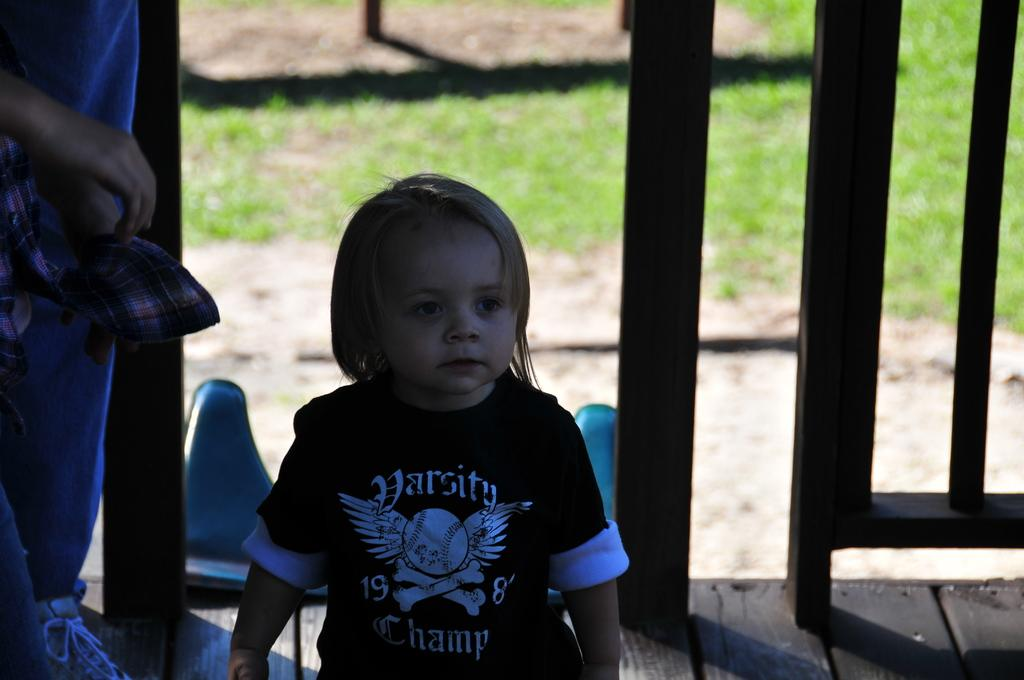How many people are in the image? There are two persons in the image. Can you describe one of the persons in the image? One of the persons is a boy. What is the boy wearing in the image? The boy is wearing a black t-shirt. What can be seen in the background of the image? There is a barricade in the background of the image. How many firemen are present in the image? There are no firemen present in the image. Can you tell me how many spiders are crawling on the boy's sock in the image? There is no sock or spiders mentioned in the image; the boy is wearing a black t-shirt. 